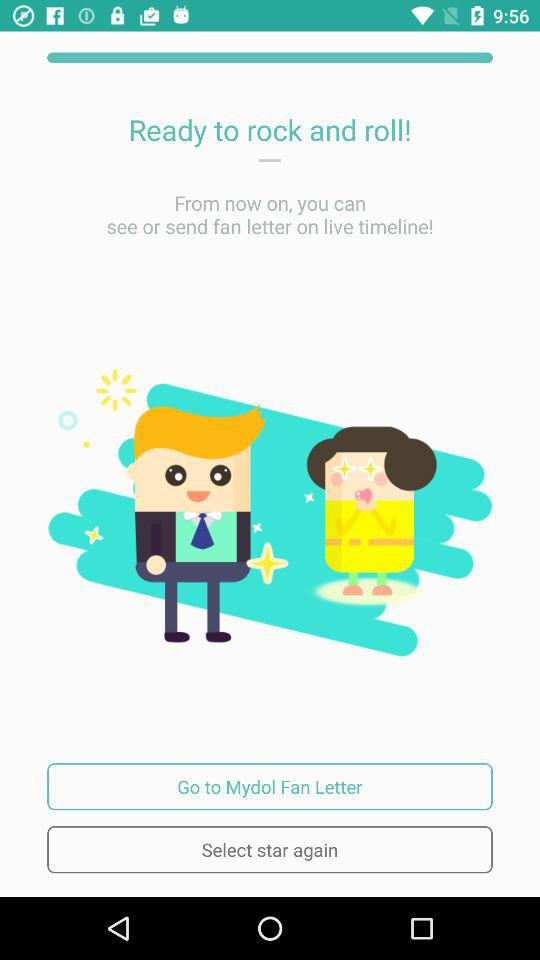What is the application name? The application name is "Mydol". 